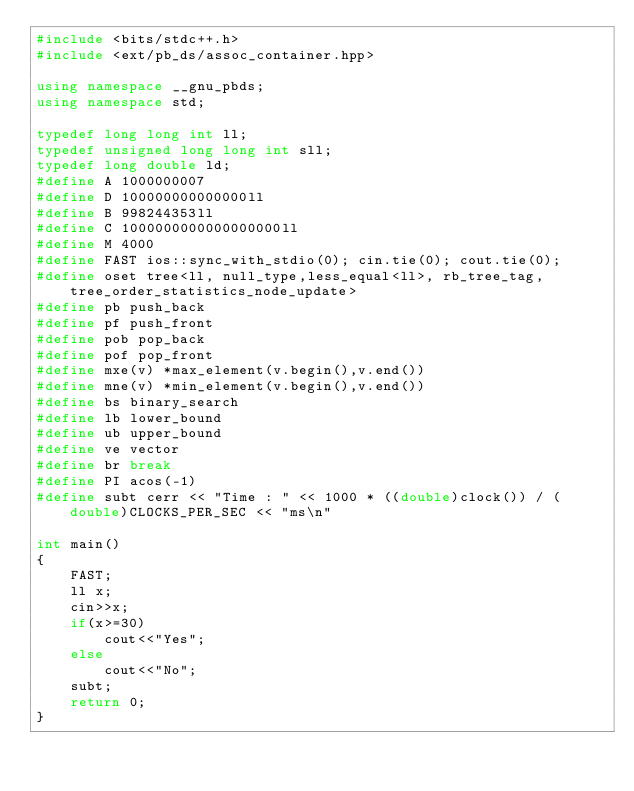Convert code to text. <code><loc_0><loc_0><loc_500><loc_500><_C++_>#include <bits/stdc++.h>
#include <ext/pb_ds/assoc_container.hpp>
 
using namespace __gnu_pbds;
using namespace std;
 
typedef long long int ll;
typedef unsigned long long int sll;
typedef long double ld;
#define A 1000000007
#define D 100000000000000ll
#define B 998244353ll
#define C 1000000000000000000ll
#define M 4000
#define FAST ios::sync_with_stdio(0); cin.tie(0); cout.tie(0);
#define oset tree<ll, null_type,less_equal<ll>, rb_tree_tag,tree_order_statistics_node_update> 
#define pb push_back
#define pf push_front
#define pob pop_back
#define pof pop_front
#define mxe(v) *max_element(v.begin(),v.end())
#define mne(v) *min_element(v.begin(),v.end())
#define bs binary_search
#define lb lower_bound
#define ub upper_bound
#define ve vector
#define br break
#define PI acos(-1)
#define subt cerr << "Time : " << 1000 * ((double)clock()) / (double)CLOCKS_PER_SEC << "ms\n" 

int main() 
{
    FAST;
    ll x;
    cin>>x;
    if(x>=30)
        cout<<"Yes";
    else
        cout<<"No";
    subt;
    return 0;
}</code> 